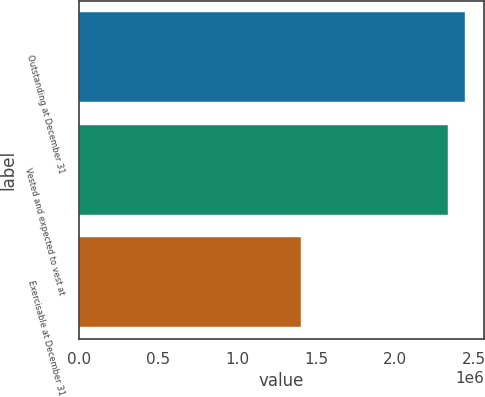<chart> <loc_0><loc_0><loc_500><loc_500><bar_chart><fcel>Outstanding at December 31<fcel>Vested and expected to vest at<fcel>Exercisable at December 31<nl><fcel>2.43936e+06<fcel>2.33219e+06<fcel>1.40413e+06<nl></chart> 